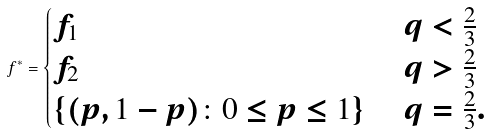<formula> <loc_0><loc_0><loc_500><loc_500>f ^ { * } = \begin{cases} f _ { 1 } & \ q < \frac { 2 } { 3 } \\ f _ { 2 } & \ q > \frac { 2 } { 3 } \\ \left \{ ( p , 1 - p ) \colon 0 \leq p \leq 1 \right \} & \ q = \frac { 2 } { 3 } . \end{cases}</formula> 